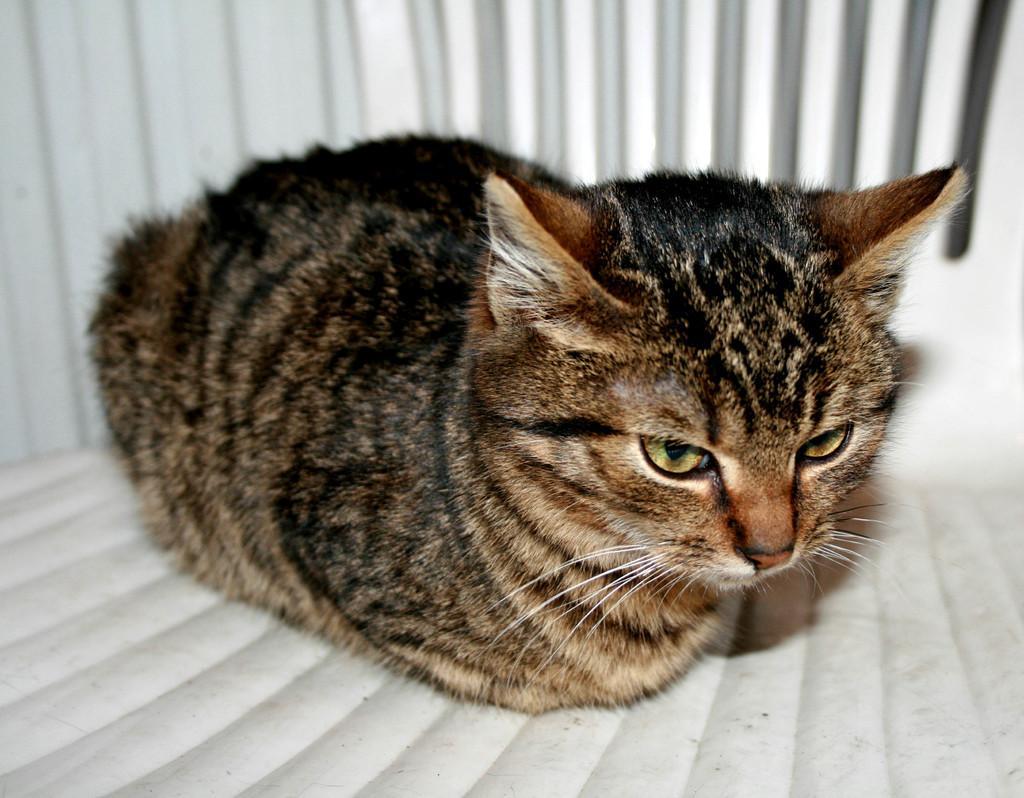Can you describe this image briefly? In this image we can see a cat and the background it looks like the wall. 